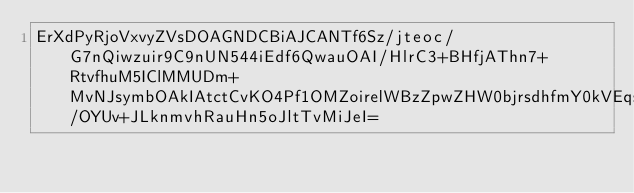<code> <loc_0><loc_0><loc_500><loc_500><_SML_>ErXdPyRjoVxvyZVsDOAGNDCBiAJCANTf6Sz/jteoc/G7nQiwzuir9C9nUN544iEdf6QwauOAI/HlrC3+BHfjAThn7+RtvfhuM5IClMMUDm+MvNJsymbOAkIAtctCvKO4Pf1OMZoirelWBzZpwZHW0bjrsdhfmY0kVEqs0T0m1iuFP5qSs/OYUv+JLknmvhRauHn5oJltTvMiJeI=</code> 